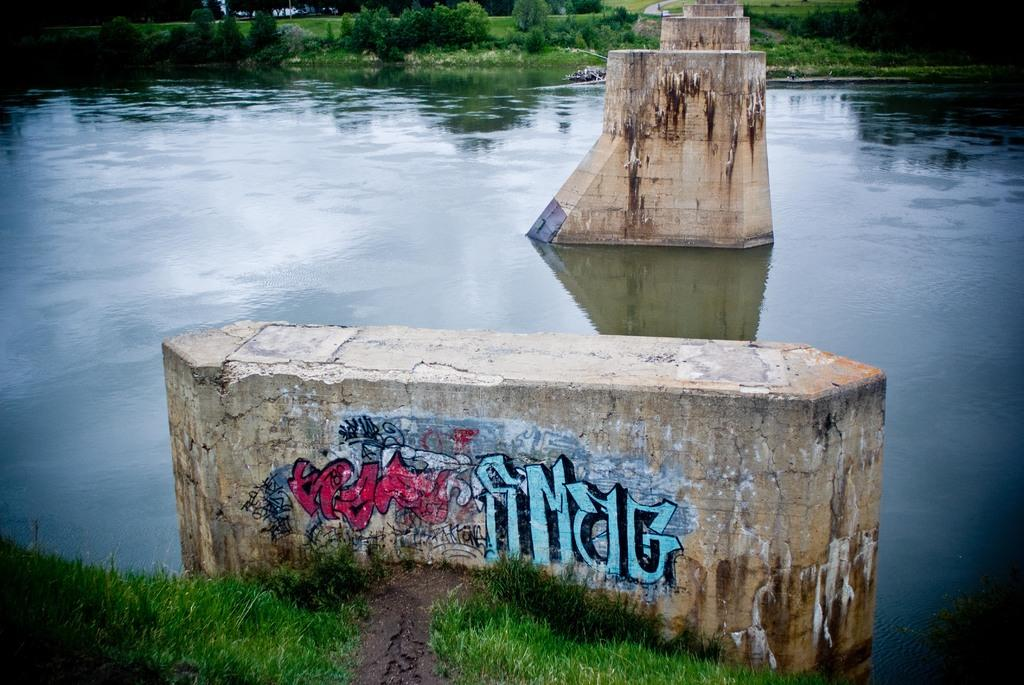What can be seen in the middle of the lake in the image? There are pillars in the middle of the lake. What type of vegetation surrounds the lake? There is grassland on either side of the lake. What type of organization is responsible for maintaining the floor in the image? There is no floor present in the image, as it is a lake with pillars in the middle. 